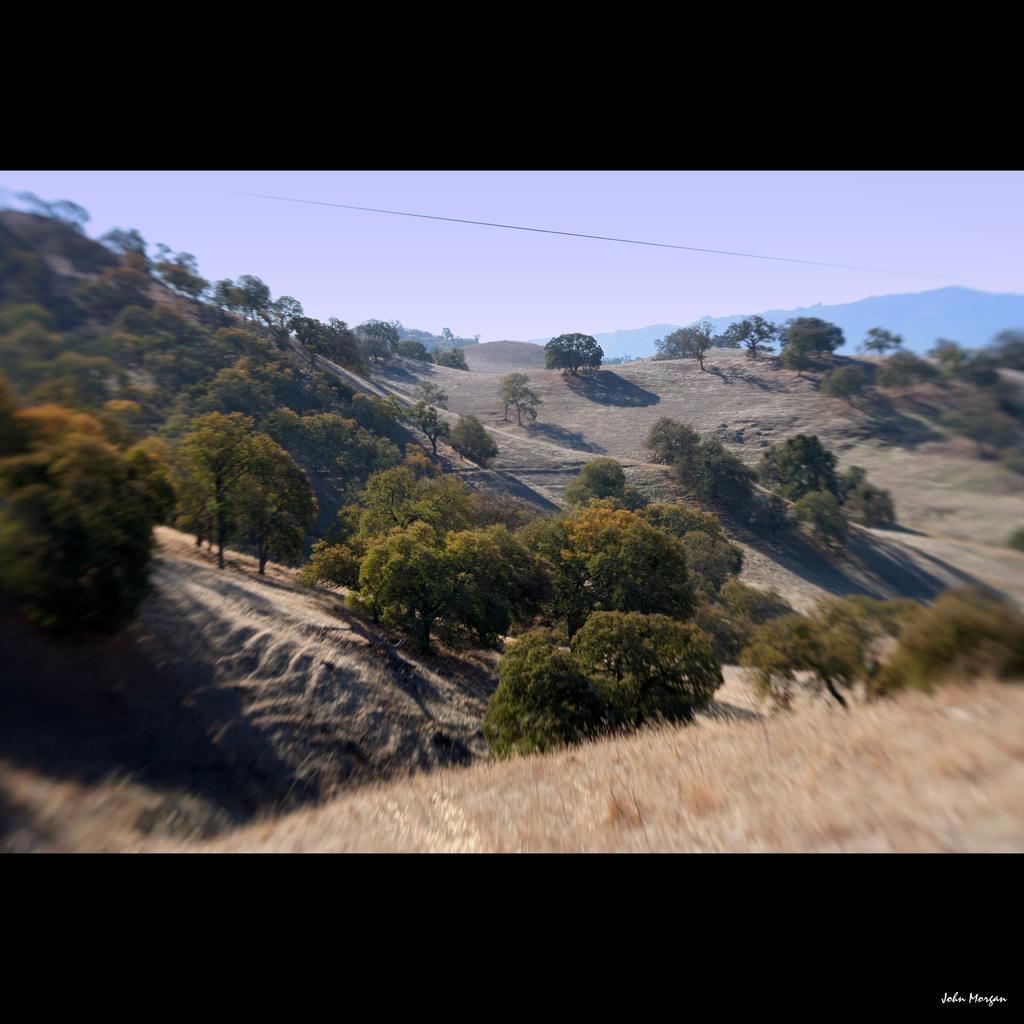What type of terrain is visible in the image? There is a hill surface with dried grass in the image. What can be seen growing on the hill slope? Trees are present on the hill slope in the image. How much of the hill is visible in the image? There is a part of the hill visible in the background of the image. What is visible in the sky in the image? The sky is visible in the background of the image. What type of tank is visible on the hill in the image? There is no tank present in the image; it features a hill with dried grass and trees. 